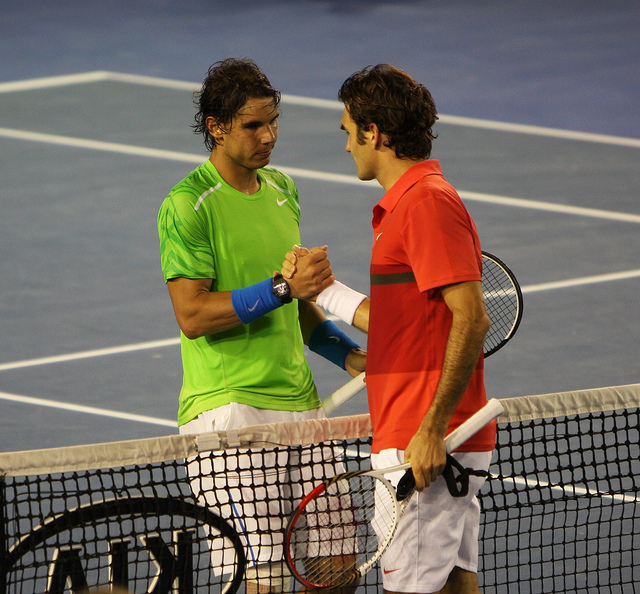Read all the text in this image. AIK 